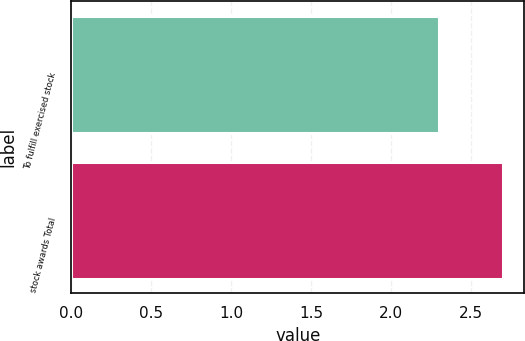Convert chart to OTSL. <chart><loc_0><loc_0><loc_500><loc_500><bar_chart><fcel>To fulfill exercised stock<fcel>stock awards Total<nl><fcel>2.3<fcel>2.7<nl></chart> 